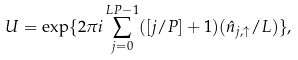<formula> <loc_0><loc_0><loc_500><loc_500>U = \exp \{ 2 \pi i \sum _ { j = 0 } ^ { L P - 1 } ( [ j / P ] + 1 ) ( \hat { n } _ { j , \uparrow } / L ) \} ,</formula> 